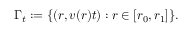<formula> <loc_0><loc_0><loc_500><loc_500>\Gamma _ { t } \colon = \{ ( r , v ( r ) t ) \colon r \in [ r _ { 0 } , r _ { 1 } ] \} .</formula> 